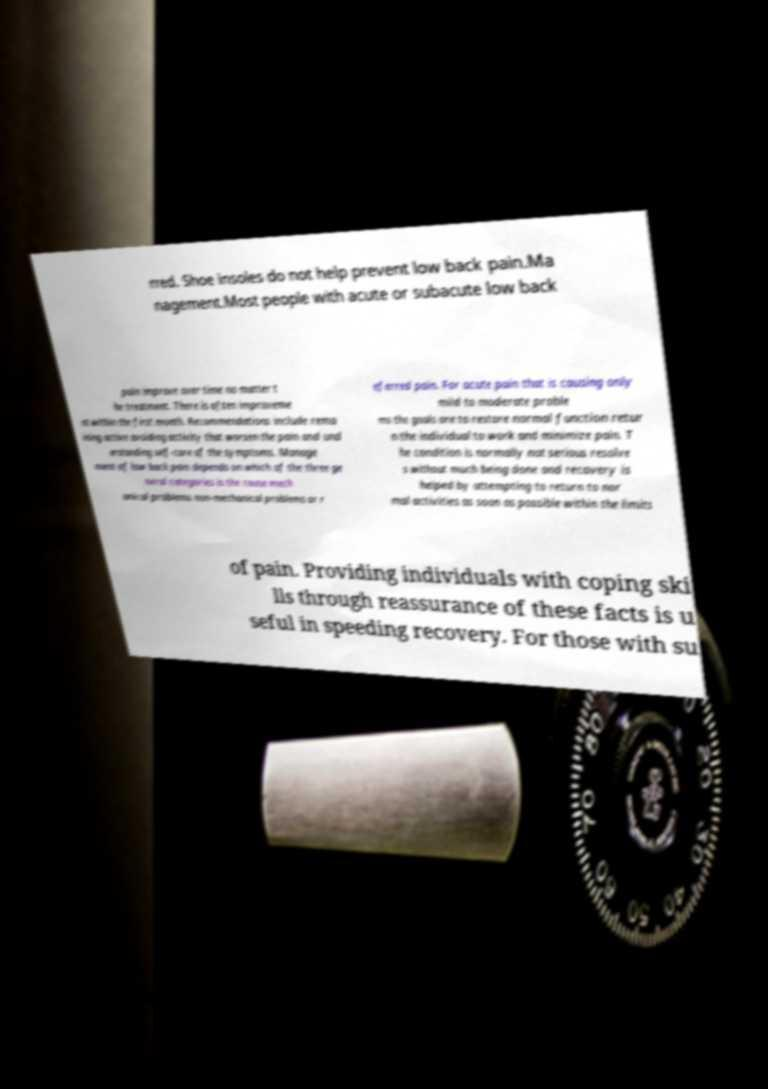Could you extract and type out the text from this image? rred. Shoe insoles do not help prevent low back pain.Ma nagement.Most people with acute or subacute low back pain improve over time no matter t he treatment. There is often improveme nt within the first month. Recommendations include rema ining active avoiding activity that worsen the pain and und erstanding self-care of the symptoms. Manage ment of low back pain depends on which of the three ge neral categories is the cause mech anical problems non-mechanical problems or r eferred pain. For acute pain that is causing only mild to moderate proble ms the goals are to restore normal function retur n the individual to work and minimize pain. T he condition is normally not serious resolve s without much being done and recovery is helped by attempting to return to nor mal activities as soon as possible within the limits of pain. Providing individuals with coping ski lls through reassurance of these facts is u seful in speeding recovery. For those with su 